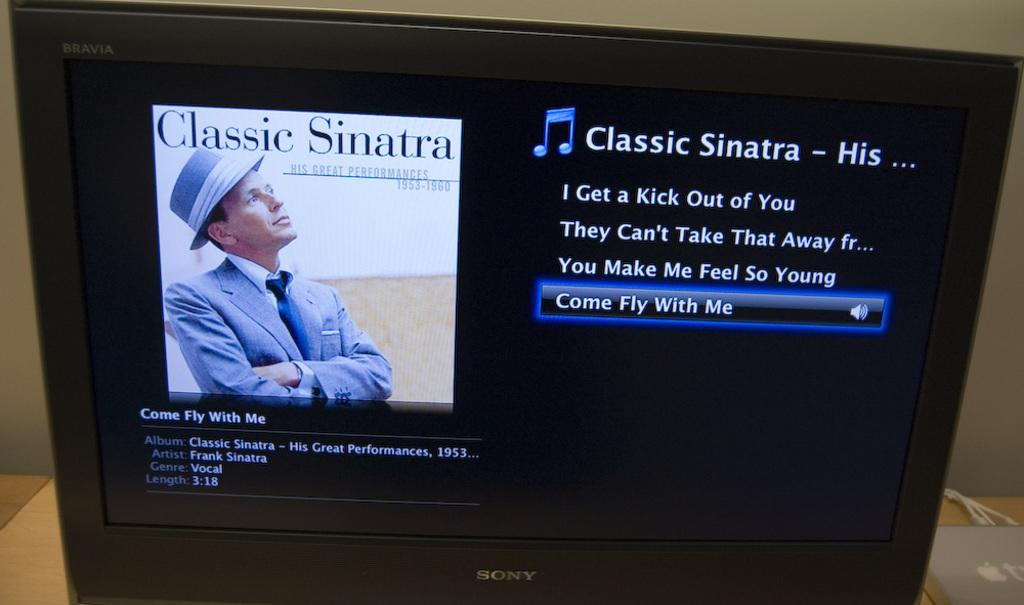<image>
Provide a brief description of the given image. A screenshot of Classic Sinatra hits with picture. 